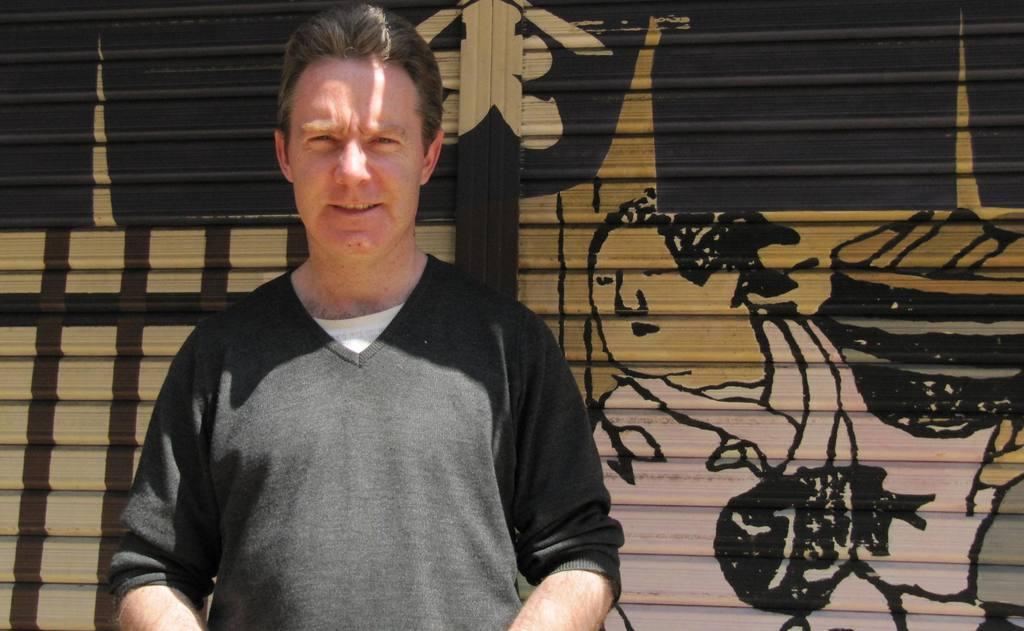Could you give a brief overview of what you see in this image? In this picture I can see a man standing, and in the background there are paintings on the shutters. 